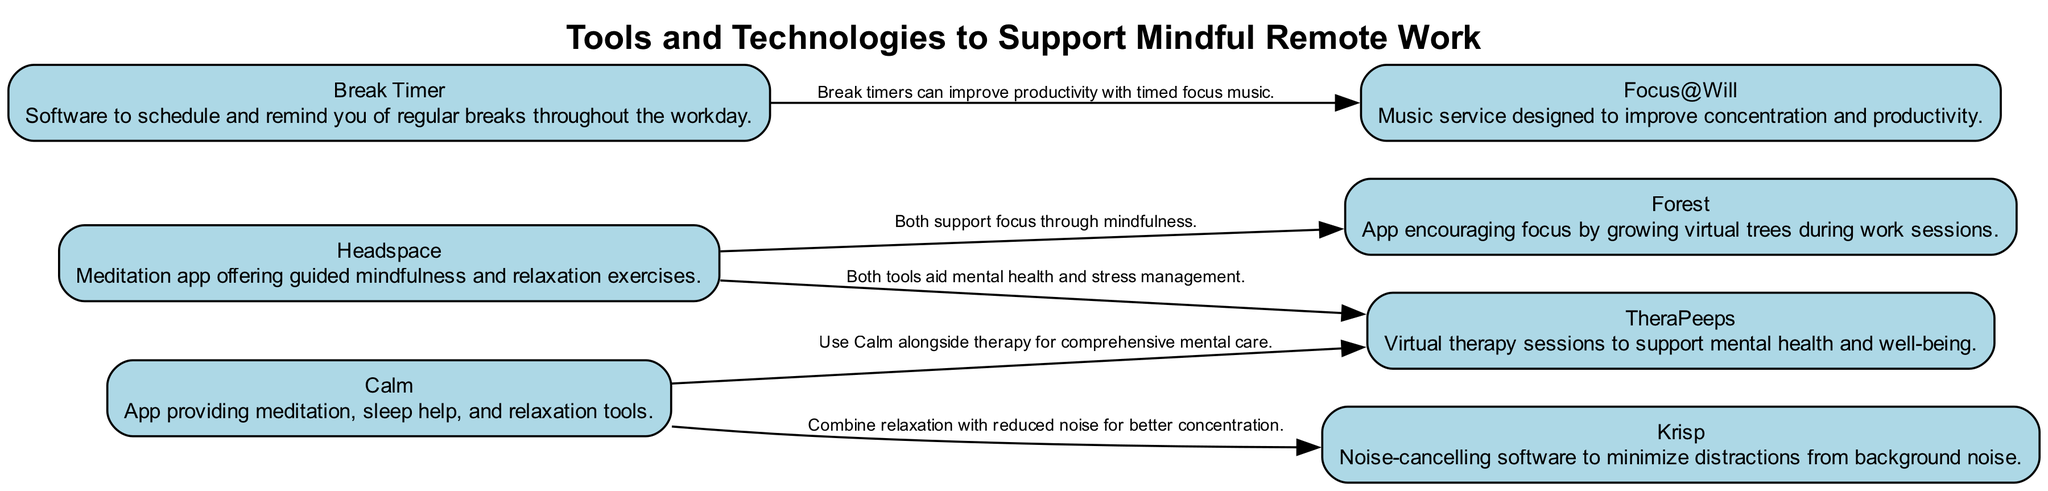What is the title of the diagram? The title of the diagram is explicitly provided at the top as "Tools and Technologies to Support Mindful Remote Work."
Answer: Tools and Technologies to Support Mindful Remote Work How many tools are listed in the diagram? Counting the nodes provided in the data, there are a total of seven tools mentioned.
Answer: 7 Which tool offers guided mindfulness and relaxation exercises? The description for the first tool in the nodes specifically states that Headspace is a meditation app offering guided mindfulness and relaxation exercises.
Answer: Headspace What relationship exists between Calm and Krisp? The diagram shows that Calm and Krisp share an edge, which states that they combine relaxation with reduced noise for better concentration.
Answer: Relationship exists (Combine relaxation with reduced noise) Which tools are connected to support mental health? The edges show that Headspace and TheraPeeps are directly related, and Calm also connects to TheraPeeps for comprehensive mental care, indicating a focus on mental health support.
Answer: Headspace, Calm, and TheraPeeps How does Break Timer relate to Focus@Will? There is a direct edge from Break Timer to Focus@Will, which describes that break timers can improve productivity with timed focus music, indicating their relationship in promoting productivity.
Answer: Break Timer improves productivity using Focus@Will Which tool encourages focus through growing virtual trees? The description for the third node, titled Forest, indicates it encourages focus by growing virtual trees during work sessions, directly answering the question.
Answer: Forest What type of software is Krisp? The description in the second node specifically states that Krisp is noise-cancelling software designed to minimize distractions from background noise.
Answer: Noise-cancelling software 